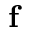<formula> <loc_0><loc_0><loc_500><loc_500>f</formula> 